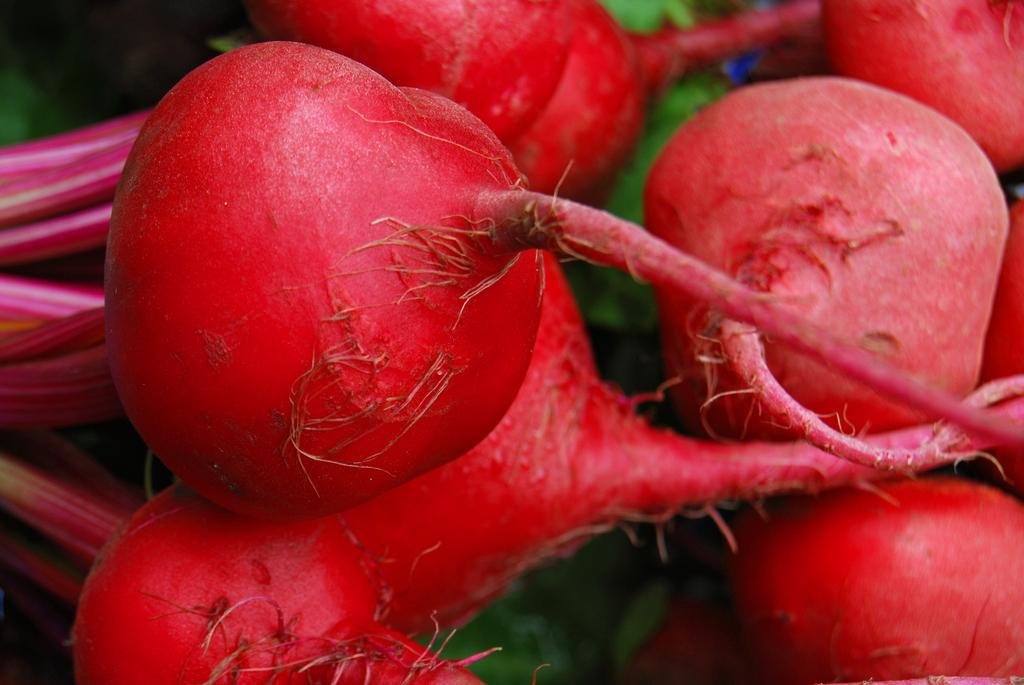What type of vegetables are featured in the image? The image is a close-up of red color root vegetables. Can you describe the color of the vegetables in the image? The root vegetables in the image are red in color. What part of the vegetables is visible in the image? The image is a close-up, so only the roots of the vegetables are visible. How much salt is sprinkled on the vegetables in the image? There is no salt visible in the image, as it only features the red color root vegetables. 